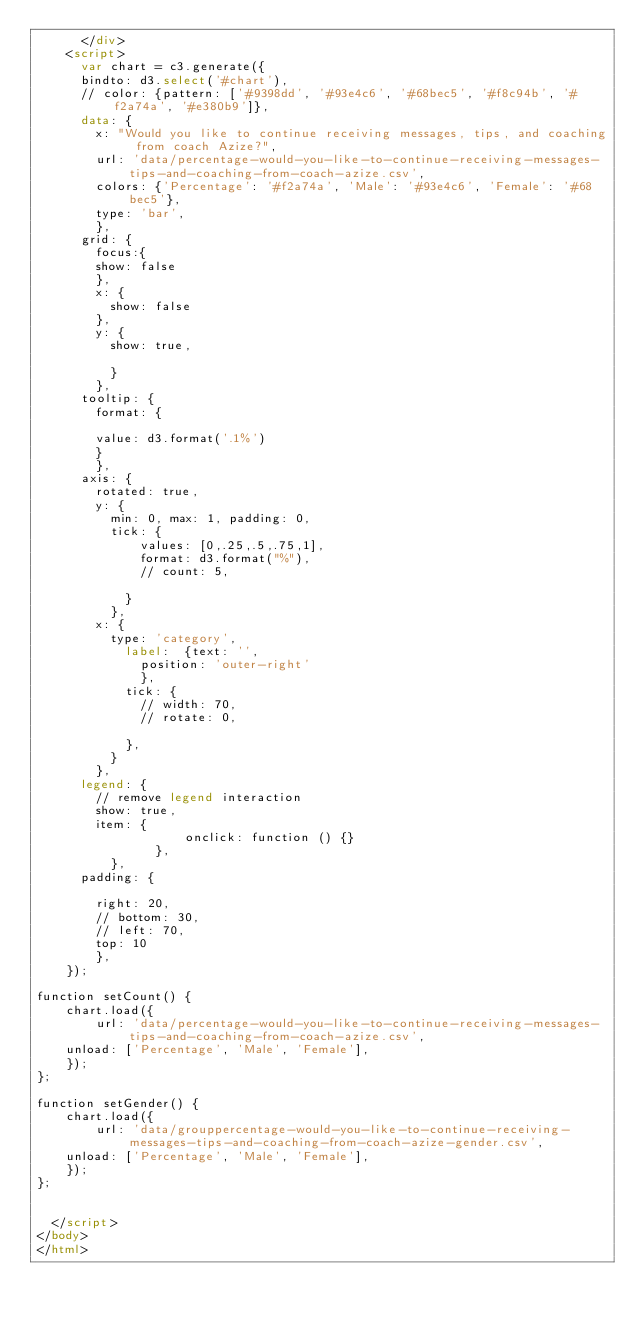Convert code to text. <code><loc_0><loc_0><loc_500><loc_500><_HTML_>	    </div>
		<script>
			var chart = c3.generate({
			bindto: d3.select('#chart'),
			// color: {pattern: ['#9398dd', '#93e4c6', '#68bec5', '#f8c94b', '#f2a74a', '#e380b9']},
			data: {
				x: "Would you like to continue receiving messages, tips, and coaching from coach Azize?",
				url: 'data/percentage-would-you-like-to-continue-receiving-messages-tips-and-coaching-from-coach-azize.csv',
				colors: {'Percentage': '#f2a74a', 'Male': '#93e4c6', 'Female': '#68bec5'},
				type: 'bar',
				},
			grid: {
				focus:{
				show: false
				},
				x: {
					show: false
				},
				y: {
					show: true,

					}
				},
			tooltip: {
				format: {

				value: d3.format('.1%')
				}
				},
			axis: {
				rotated: true,
				y: {
					min: 0, max: 1, padding: 0,
					tick: {
							values: [0,.25,.5,.75,1],
							format: d3.format("%"),
							// count: 5,

						}
					},
				x: {
					type: 'category',
						label: 	{text: '',
							position: 'outer-right'
							},
						tick: {
							// width: 70,
							// rotate: 0,

						},
					}
				},
			legend: {
				// remove legend interaction
				show: true,
				item: {
				            onclick: function () {}
				        },
					},
			padding: {

				right: 20,
				// bottom: 30,
				// left: 70,
				top: 10
				},
		});

function setCount() {
    chart.load({
        url: 'data/percentage-would-you-like-to-continue-receiving-messages-tips-and-coaching-from-coach-azize.csv',
		unload: ['Percentage', 'Male', 'Female'],
    });
};

function setGender() {
    chart.load({
        url: 'data/grouppercentage-would-you-like-to-continue-receiving-messages-tips-and-coaching-from-coach-azize-gender.csv',
		unload: ['Percentage', 'Male', 'Female'],
    });
};


	</script>
</body>
</html></code> 